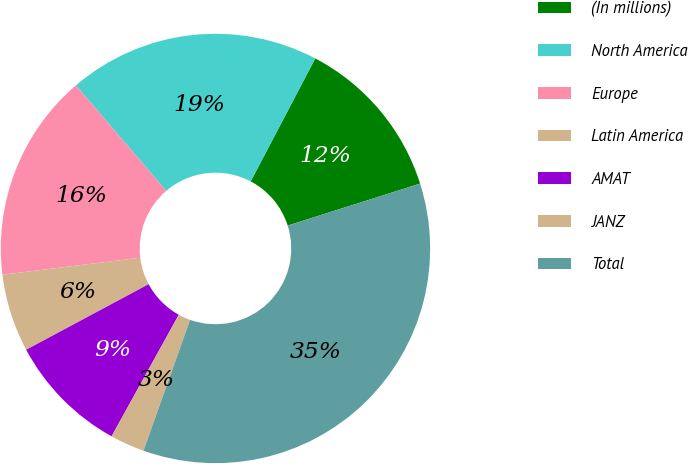Convert chart to OTSL. <chart><loc_0><loc_0><loc_500><loc_500><pie_chart><fcel>(In millions)<fcel>North America<fcel>Europe<fcel>Latin America<fcel>AMAT<fcel>JANZ<fcel>Total<nl><fcel>12.42%<fcel>18.96%<fcel>15.69%<fcel>5.87%<fcel>9.14%<fcel>2.6%<fcel>35.33%<nl></chart> 